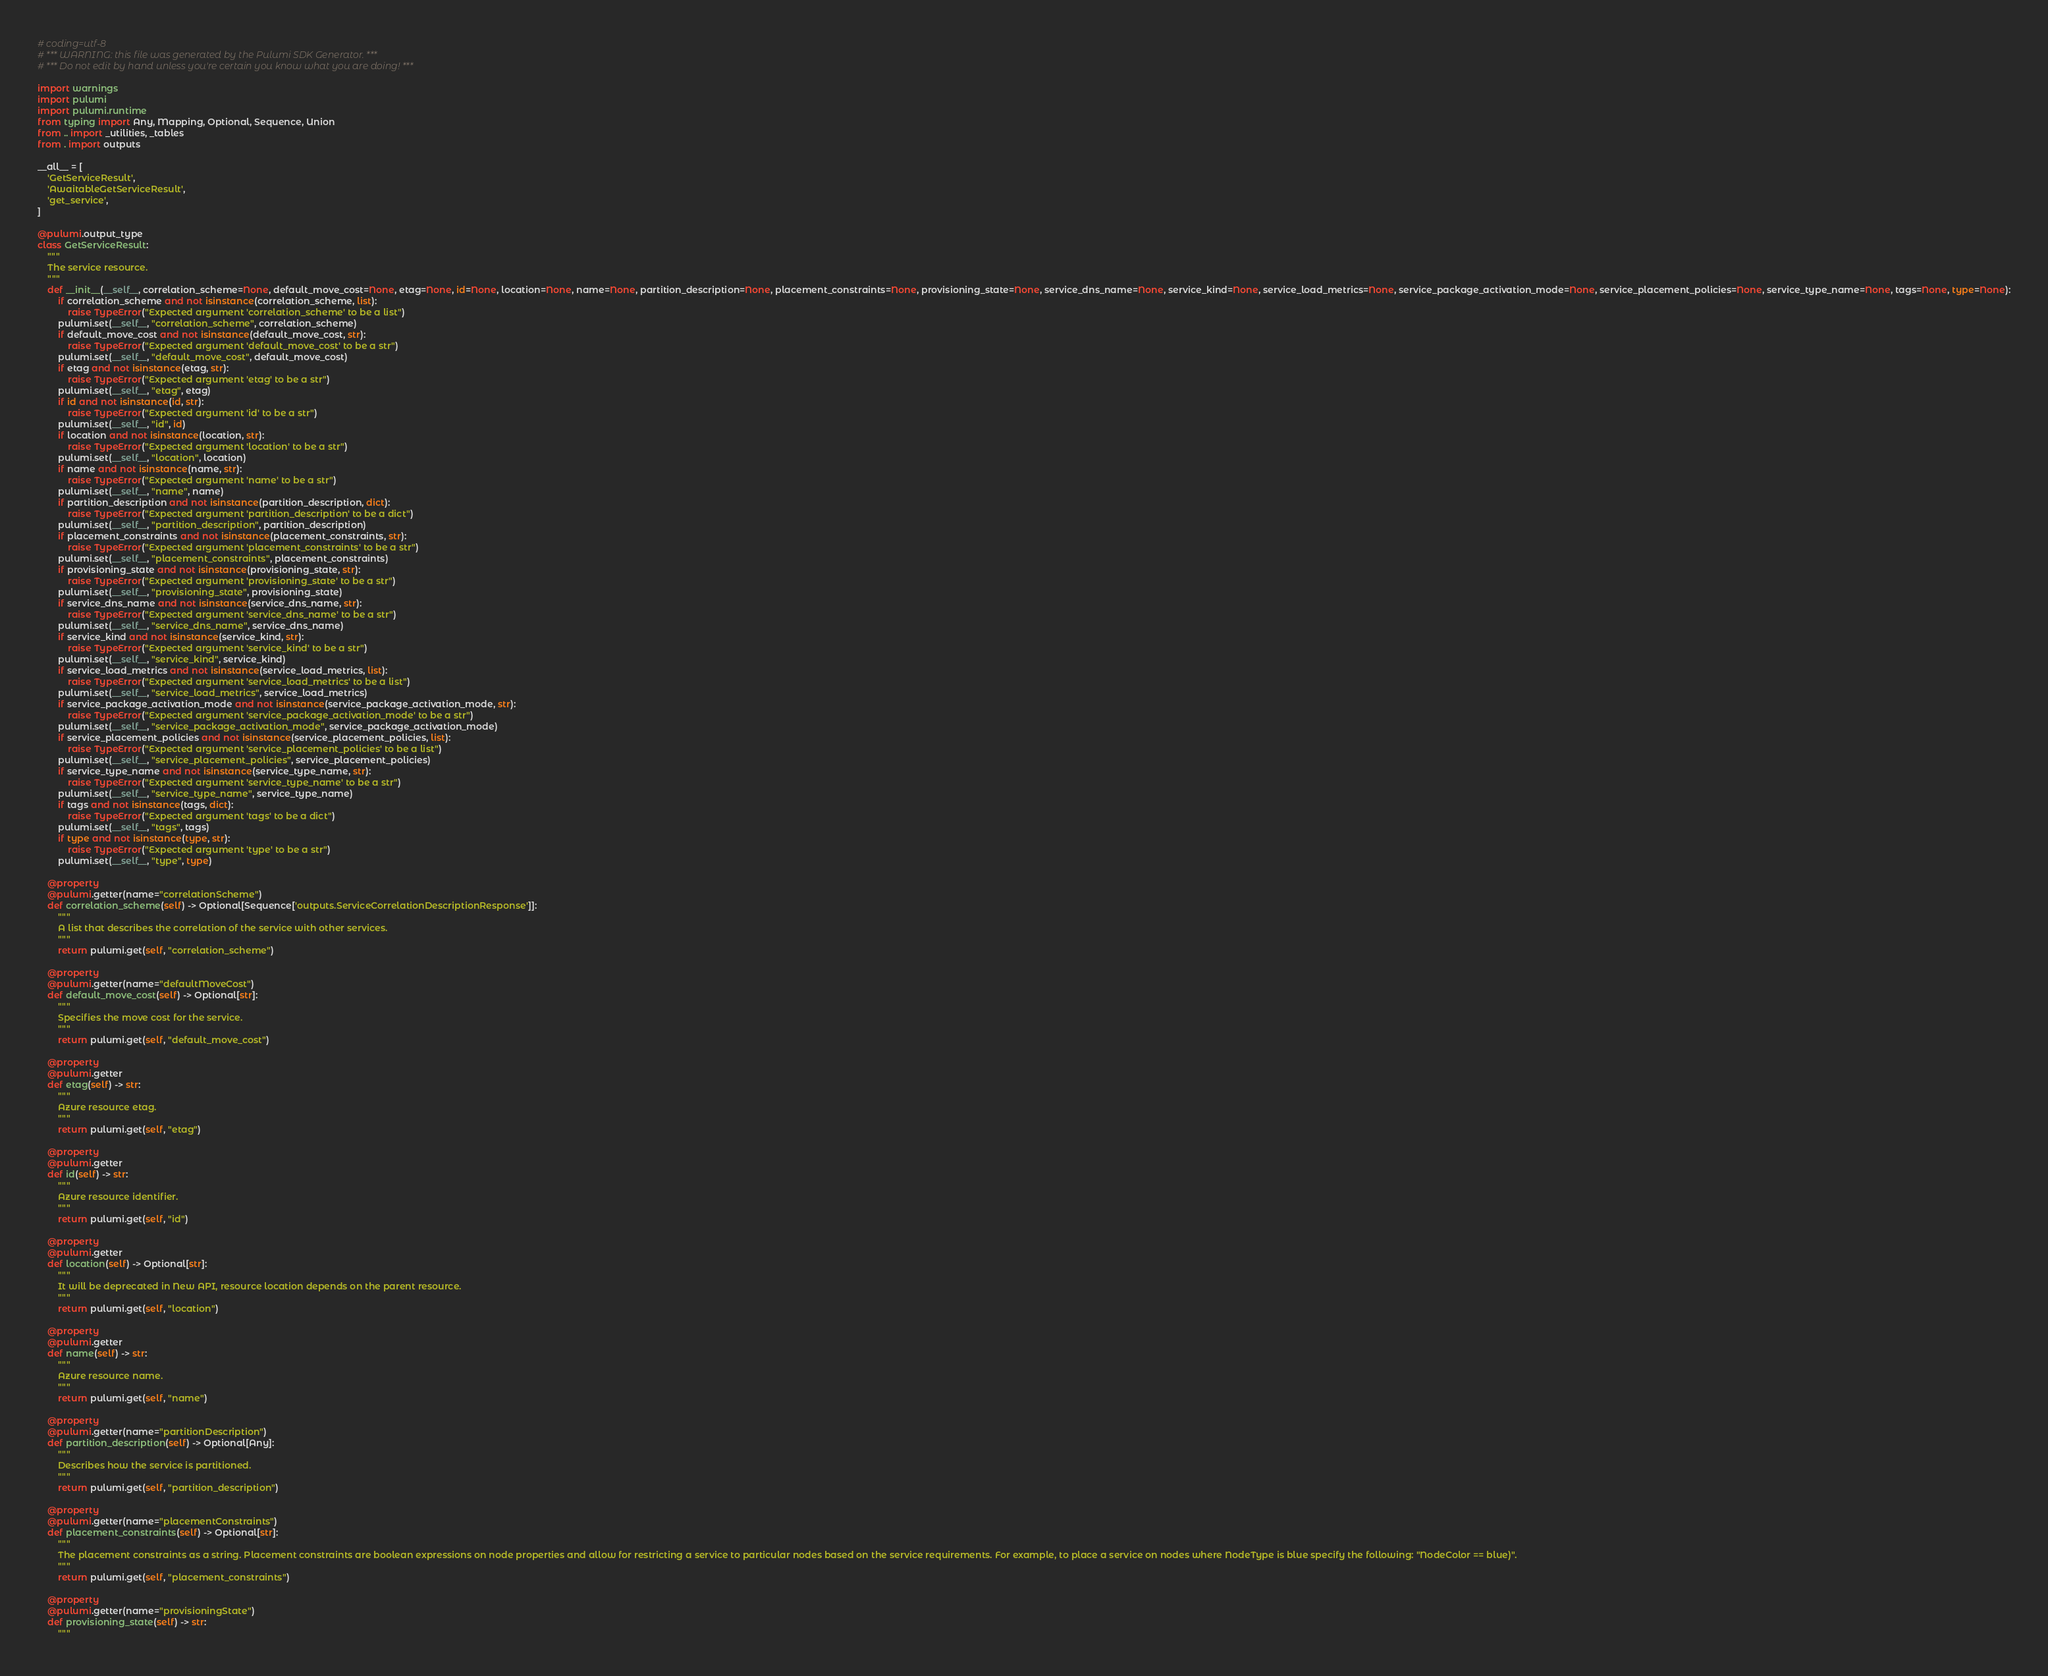Convert code to text. <code><loc_0><loc_0><loc_500><loc_500><_Python_># coding=utf-8
# *** WARNING: this file was generated by the Pulumi SDK Generator. ***
# *** Do not edit by hand unless you're certain you know what you are doing! ***

import warnings
import pulumi
import pulumi.runtime
from typing import Any, Mapping, Optional, Sequence, Union
from .. import _utilities, _tables
from . import outputs

__all__ = [
    'GetServiceResult',
    'AwaitableGetServiceResult',
    'get_service',
]

@pulumi.output_type
class GetServiceResult:
    """
    The service resource.
    """
    def __init__(__self__, correlation_scheme=None, default_move_cost=None, etag=None, id=None, location=None, name=None, partition_description=None, placement_constraints=None, provisioning_state=None, service_dns_name=None, service_kind=None, service_load_metrics=None, service_package_activation_mode=None, service_placement_policies=None, service_type_name=None, tags=None, type=None):
        if correlation_scheme and not isinstance(correlation_scheme, list):
            raise TypeError("Expected argument 'correlation_scheme' to be a list")
        pulumi.set(__self__, "correlation_scheme", correlation_scheme)
        if default_move_cost and not isinstance(default_move_cost, str):
            raise TypeError("Expected argument 'default_move_cost' to be a str")
        pulumi.set(__self__, "default_move_cost", default_move_cost)
        if etag and not isinstance(etag, str):
            raise TypeError("Expected argument 'etag' to be a str")
        pulumi.set(__self__, "etag", etag)
        if id and not isinstance(id, str):
            raise TypeError("Expected argument 'id' to be a str")
        pulumi.set(__self__, "id", id)
        if location and not isinstance(location, str):
            raise TypeError("Expected argument 'location' to be a str")
        pulumi.set(__self__, "location", location)
        if name and not isinstance(name, str):
            raise TypeError("Expected argument 'name' to be a str")
        pulumi.set(__self__, "name", name)
        if partition_description and not isinstance(partition_description, dict):
            raise TypeError("Expected argument 'partition_description' to be a dict")
        pulumi.set(__self__, "partition_description", partition_description)
        if placement_constraints and not isinstance(placement_constraints, str):
            raise TypeError("Expected argument 'placement_constraints' to be a str")
        pulumi.set(__self__, "placement_constraints", placement_constraints)
        if provisioning_state and not isinstance(provisioning_state, str):
            raise TypeError("Expected argument 'provisioning_state' to be a str")
        pulumi.set(__self__, "provisioning_state", provisioning_state)
        if service_dns_name and not isinstance(service_dns_name, str):
            raise TypeError("Expected argument 'service_dns_name' to be a str")
        pulumi.set(__self__, "service_dns_name", service_dns_name)
        if service_kind and not isinstance(service_kind, str):
            raise TypeError("Expected argument 'service_kind' to be a str")
        pulumi.set(__self__, "service_kind", service_kind)
        if service_load_metrics and not isinstance(service_load_metrics, list):
            raise TypeError("Expected argument 'service_load_metrics' to be a list")
        pulumi.set(__self__, "service_load_metrics", service_load_metrics)
        if service_package_activation_mode and not isinstance(service_package_activation_mode, str):
            raise TypeError("Expected argument 'service_package_activation_mode' to be a str")
        pulumi.set(__self__, "service_package_activation_mode", service_package_activation_mode)
        if service_placement_policies and not isinstance(service_placement_policies, list):
            raise TypeError("Expected argument 'service_placement_policies' to be a list")
        pulumi.set(__self__, "service_placement_policies", service_placement_policies)
        if service_type_name and not isinstance(service_type_name, str):
            raise TypeError("Expected argument 'service_type_name' to be a str")
        pulumi.set(__self__, "service_type_name", service_type_name)
        if tags and not isinstance(tags, dict):
            raise TypeError("Expected argument 'tags' to be a dict")
        pulumi.set(__self__, "tags", tags)
        if type and not isinstance(type, str):
            raise TypeError("Expected argument 'type' to be a str")
        pulumi.set(__self__, "type", type)

    @property
    @pulumi.getter(name="correlationScheme")
    def correlation_scheme(self) -> Optional[Sequence['outputs.ServiceCorrelationDescriptionResponse']]:
        """
        A list that describes the correlation of the service with other services.
        """
        return pulumi.get(self, "correlation_scheme")

    @property
    @pulumi.getter(name="defaultMoveCost")
    def default_move_cost(self) -> Optional[str]:
        """
        Specifies the move cost for the service.
        """
        return pulumi.get(self, "default_move_cost")

    @property
    @pulumi.getter
    def etag(self) -> str:
        """
        Azure resource etag.
        """
        return pulumi.get(self, "etag")

    @property
    @pulumi.getter
    def id(self) -> str:
        """
        Azure resource identifier.
        """
        return pulumi.get(self, "id")

    @property
    @pulumi.getter
    def location(self) -> Optional[str]:
        """
        It will be deprecated in New API, resource location depends on the parent resource.
        """
        return pulumi.get(self, "location")

    @property
    @pulumi.getter
    def name(self) -> str:
        """
        Azure resource name.
        """
        return pulumi.get(self, "name")

    @property
    @pulumi.getter(name="partitionDescription")
    def partition_description(self) -> Optional[Any]:
        """
        Describes how the service is partitioned.
        """
        return pulumi.get(self, "partition_description")

    @property
    @pulumi.getter(name="placementConstraints")
    def placement_constraints(self) -> Optional[str]:
        """
        The placement constraints as a string. Placement constraints are boolean expressions on node properties and allow for restricting a service to particular nodes based on the service requirements. For example, to place a service on nodes where NodeType is blue specify the following: "NodeColor == blue)".
        """
        return pulumi.get(self, "placement_constraints")

    @property
    @pulumi.getter(name="provisioningState")
    def provisioning_state(self) -> str:
        """</code> 